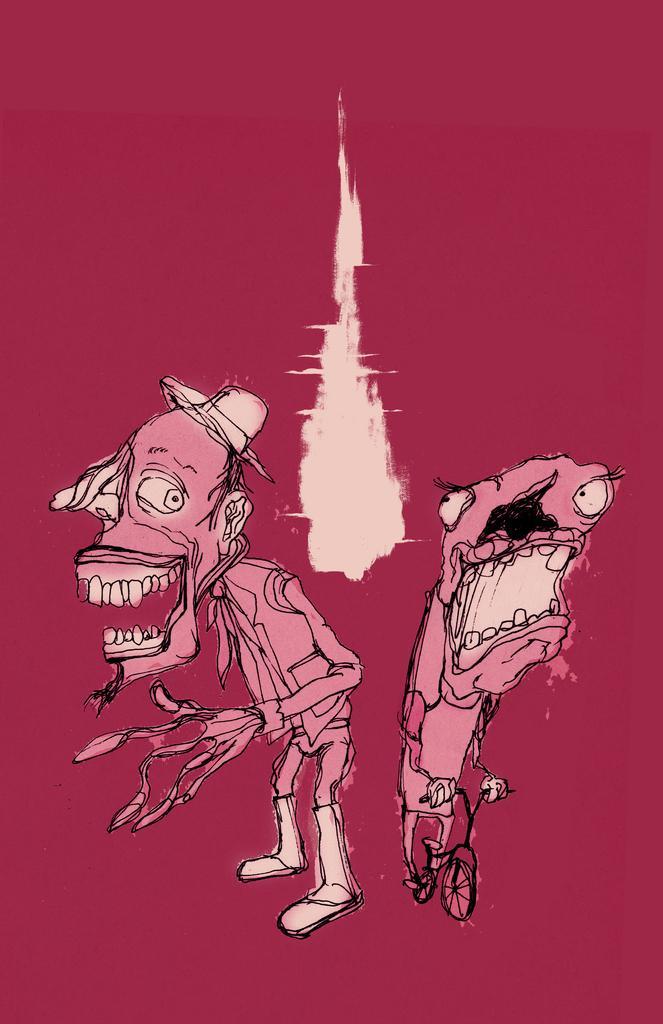Please provide a concise description of this image. In this picture we can see a drawing in pink color with cartoon images and a cycle. 